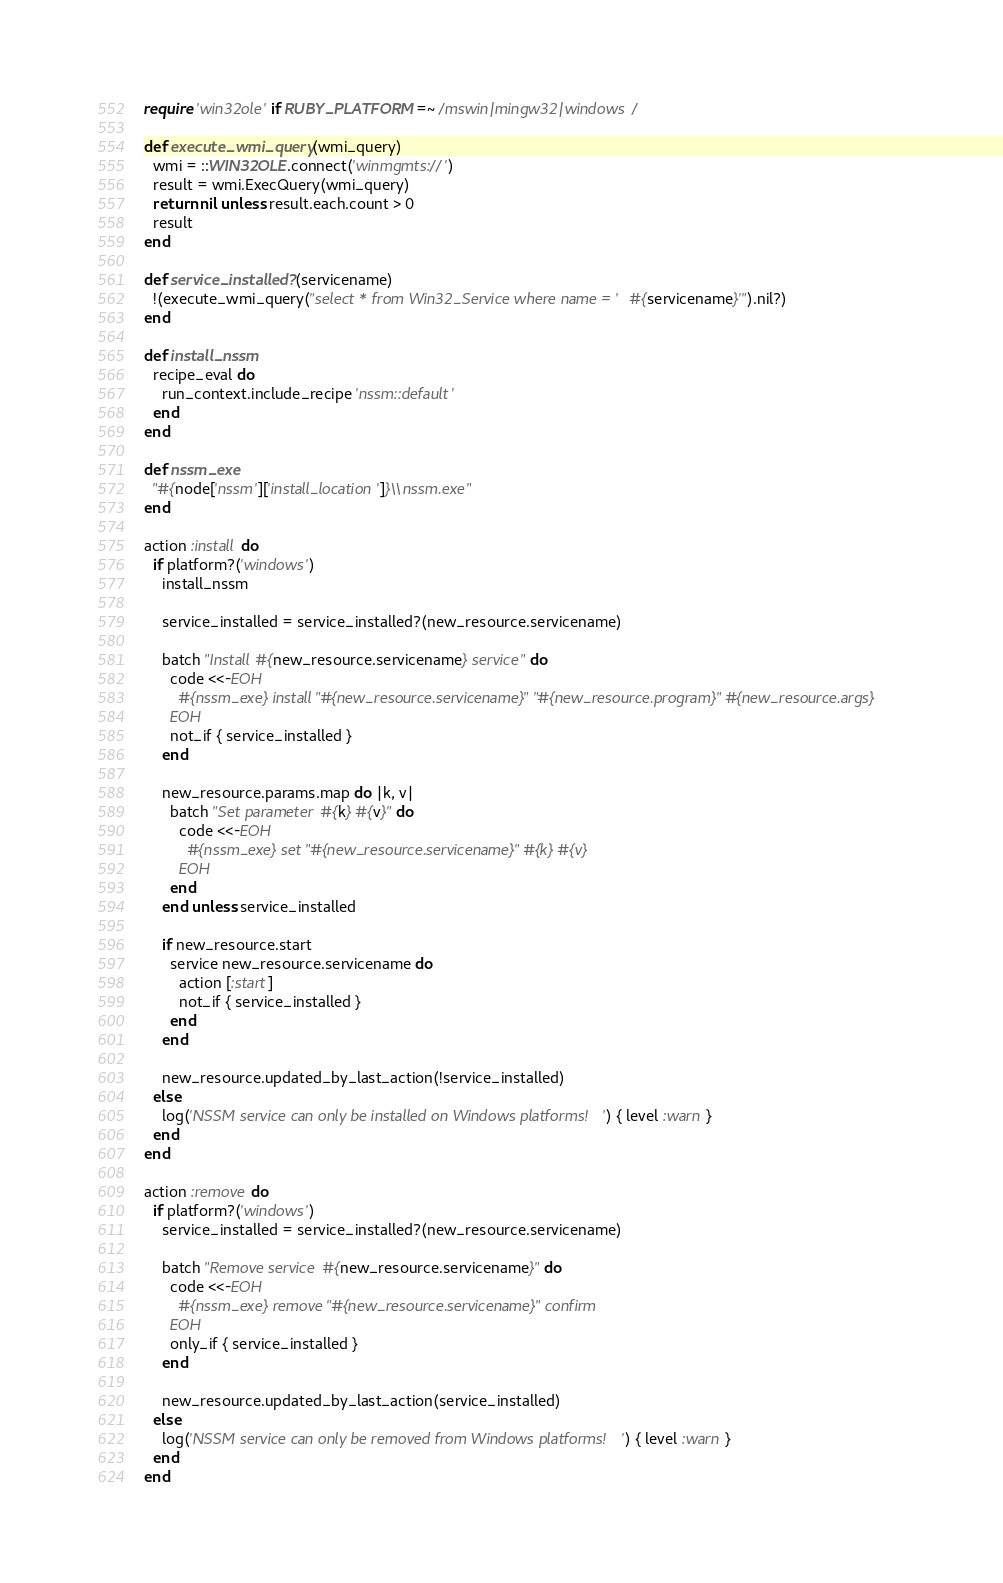<code> <loc_0><loc_0><loc_500><loc_500><_Ruby_>require 'win32ole' if RUBY_PLATFORM =~ /mswin|mingw32|windows/

def execute_wmi_query(wmi_query)
  wmi = ::WIN32OLE.connect('winmgmts://')
  result = wmi.ExecQuery(wmi_query)
  return nil unless result.each.count > 0
  result
end

def service_installed?(servicename)
  !(execute_wmi_query("select * from Win32_Service where name = '#{servicename}'").nil?)
end

def install_nssm
  recipe_eval do
    run_context.include_recipe 'nssm::default'
  end
end

def nssm_exe
  "#{node['nssm']['install_location']}\\nssm.exe"
end

action :install do
  if platform?('windows')
    install_nssm

    service_installed = service_installed?(new_resource.servicename)

    batch "Install #{new_resource.servicename} service" do
      code <<-EOH
        #{nssm_exe} install "#{new_resource.servicename}" "#{new_resource.program}" #{new_resource.args}
      EOH
      not_if { service_installed }
    end

    new_resource.params.map do |k, v|
      batch "Set parameter #{k} #{v}" do
        code <<-EOH
          #{nssm_exe} set "#{new_resource.servicename}" #{k} #{v}
        EOH
      end
    end unless service_installed

    if new_resource.start
      service new_resource.servicename do
        action [:start]
        not_if { service_installed }
      end
    end

    new_resource.updated_by_last_action(!service_installed)
  else
    log('NSSM service can only be installed on Windows platforms!') { level :warn }
  end
end

action :remove do
  if platform?('windows')
    service_installed = service_installed?(new_resource.servicename)

    batch "Remove service #{new_resource.servicename}" do
      code <<-EOH
        #{nssm_exe} remove "#{new_resource.servicename}" confirm
      EOH
      only_if { service_installed }
    end

    new_resource.updated_by_last_action(service_installed)
  else
    log('NSSM service can only be removed from Windows platforms!') { level :warn }
  end
end
</code> 